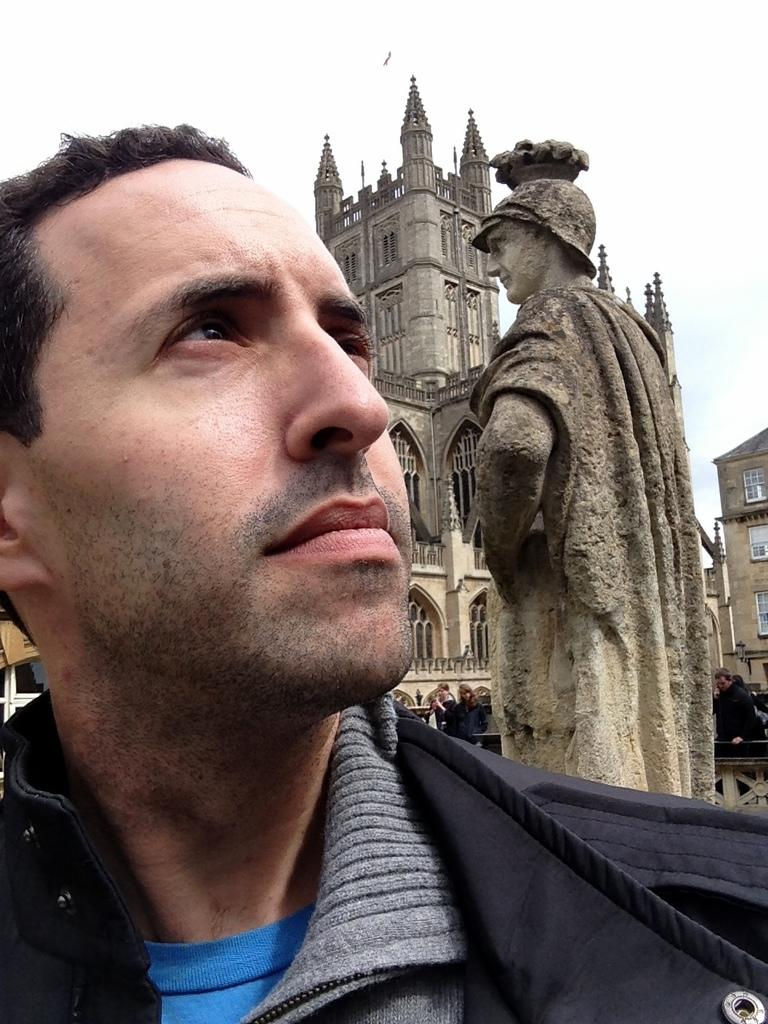Who or what is the main subject in the center of the image? There is a person in the center of the image. What can be seen in the background of the image? There is a statue and a building in the background of the image. Are there any other people visible in the image? Yes, there is at least one other person in the background of the image. What part of the natural environment is visible in the image? The sky is visible in the background of the image. What type of caption is written on the statue in the image? There is no caption visible on the statue in the image. How does the friction between the person and the ground affect their movement in the image? The image does not show any movement of the person, so it is not possible to determine the effect of friction on their movement. 